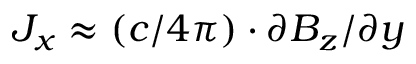Convert formula to latex. <formula><loc_0><loc_0><loc_500><loc_500>J _ { x } \approx ( c / 4 \pi ) \cdot \partial B _ { z } / \partial y</formula> 